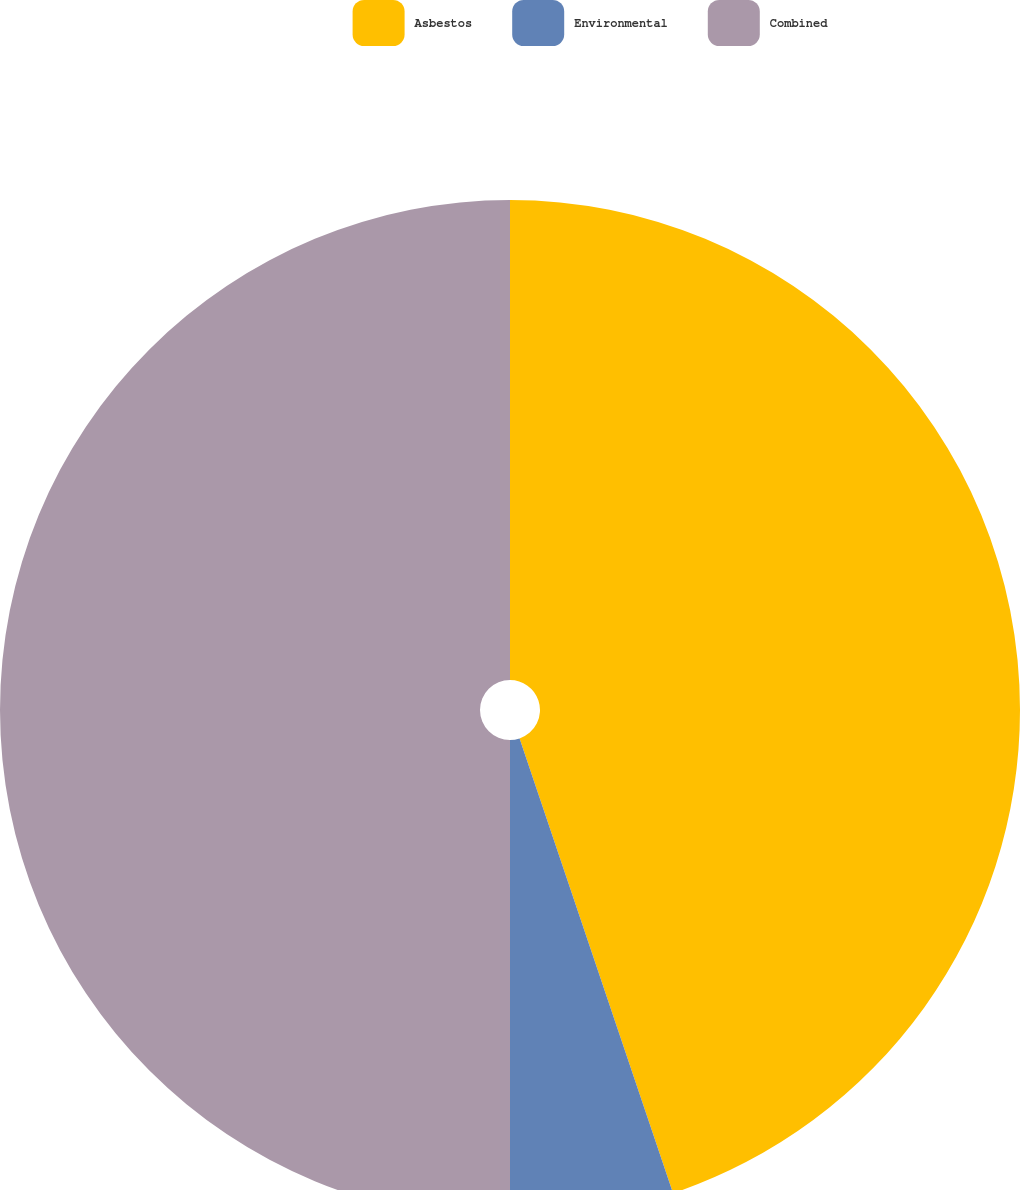<chart> <loc_0><loc_0><loc_500><loc_500><pie_chart><fcel>Asbestos<fcel>Environmental<fcel>Combined<nl><fcel>44.82%<fcel>5.18%<fcel>50.0%<nl></chart> 